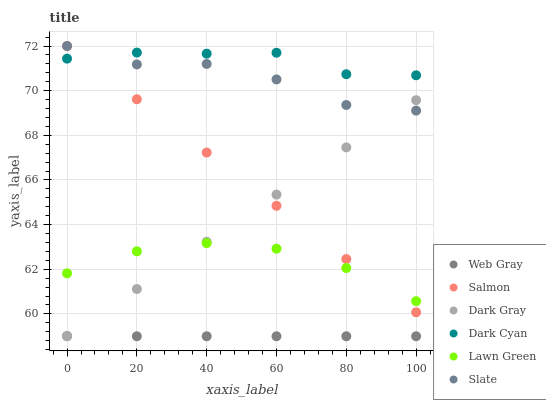Does Web Gray have the minimum area under the curve?
Answer yes or no. Yes. Does Dark Cyan have the maximum area under the curve?
Answer yes or no. Yes. Does Slate have the minimum area under the curve?
Answer yes or no. No. Does Slate have the maximum area under the curve?
Answer yes or no. No. Is Salmon the smoothest?
Answer yes or no. Yes. Is Slate the roughest?
Answer yes or no. Yes. Is Web Gray the smoothest?
Answer yes or no. No. Is Web Gray the roughest?
Answer yes or no. No. Does Web Gray have the lowest value?
Answer yes or no. Yes. Does Slate have the lowest value?
Answer yes or no. No. Does Salmon have the highest value?
Answer yes or no. Yes. Does Web Gray have the highest value?
Answer yes or no. No. Is Web Gray less than Lawn Green?
Answer yes or no. Yes. Is Salmon greater than Web Gray?
Answer yes or no. Yes. Does Slate intersect Dark Cyan?
Answer yes or no. Yes. Is Slate less than Dark Cyan?
Answer yes or no. No. Is Slate greater than Dark Cyan?
Answer yes or no. No. Does Web Gray intersect Lawn Green?
Answer yes or no. No. 